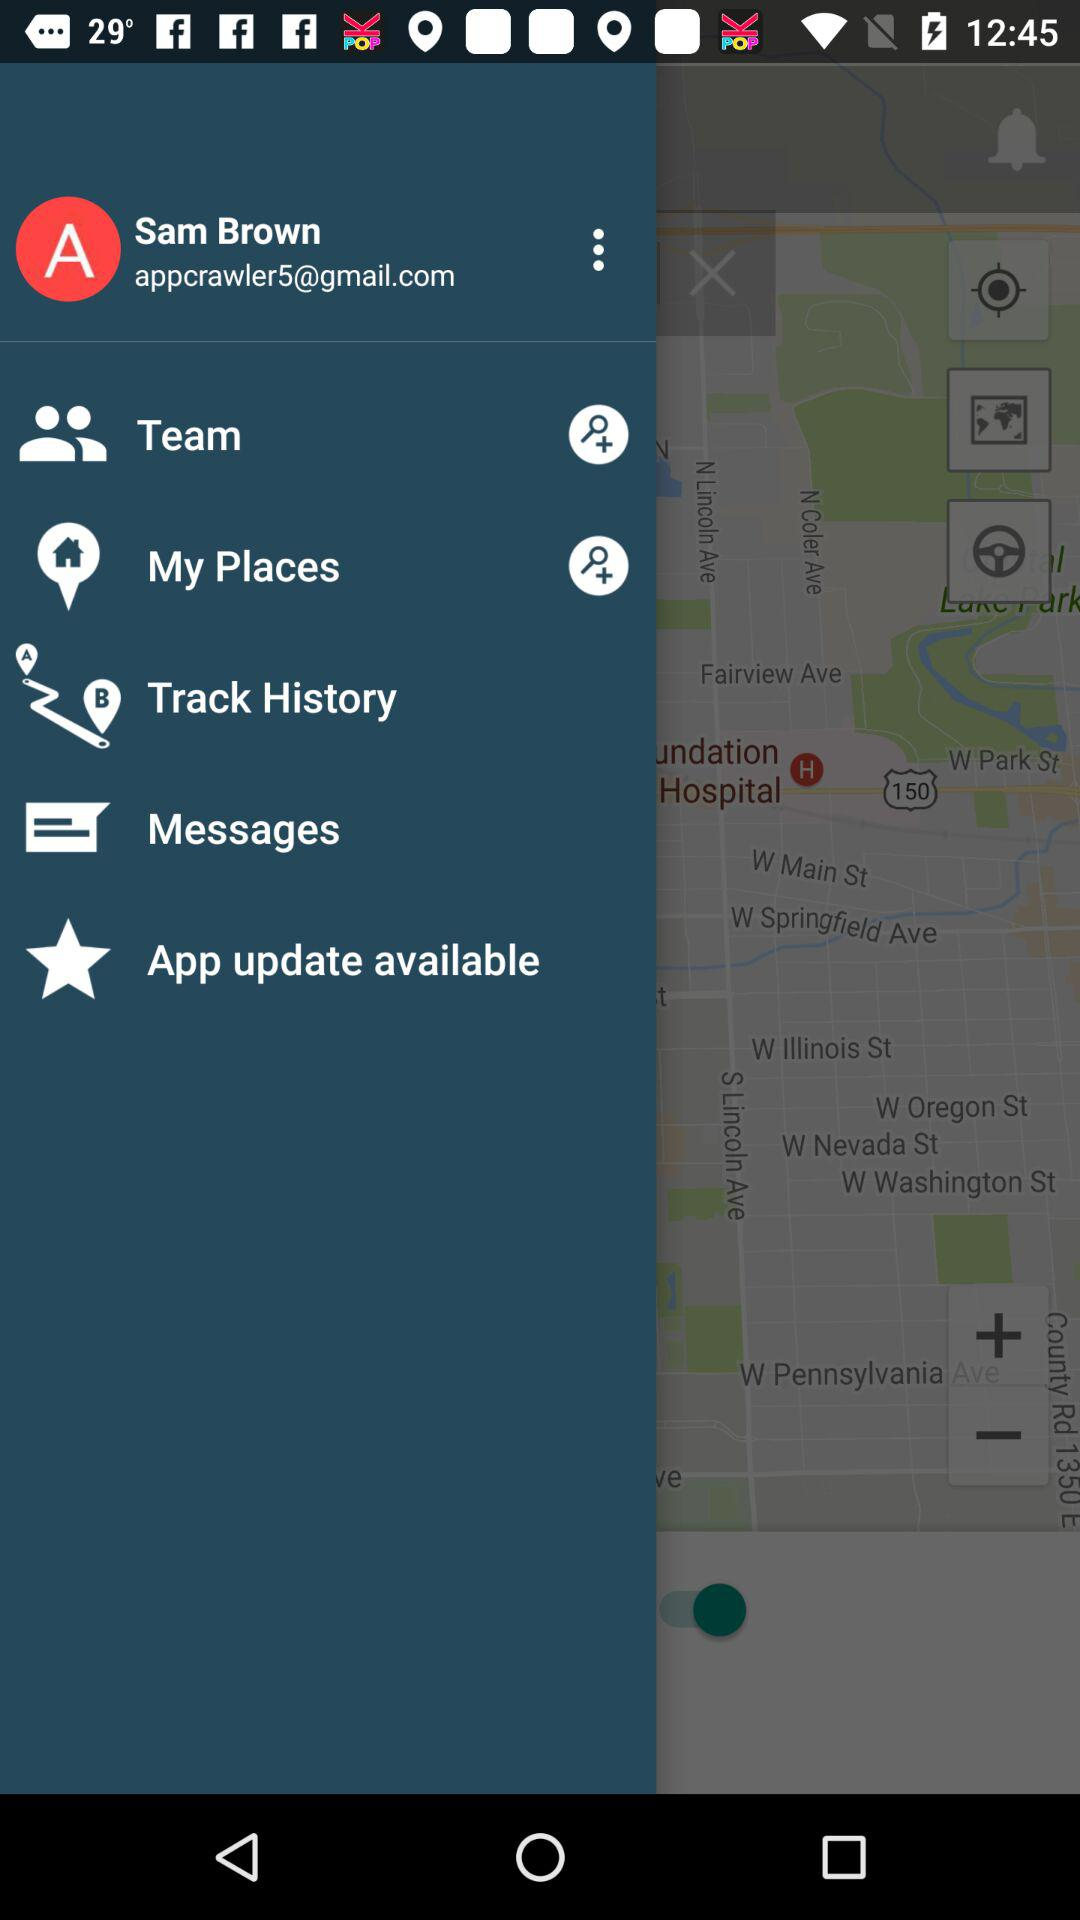What is the user name? The user name is Sam Brown. 